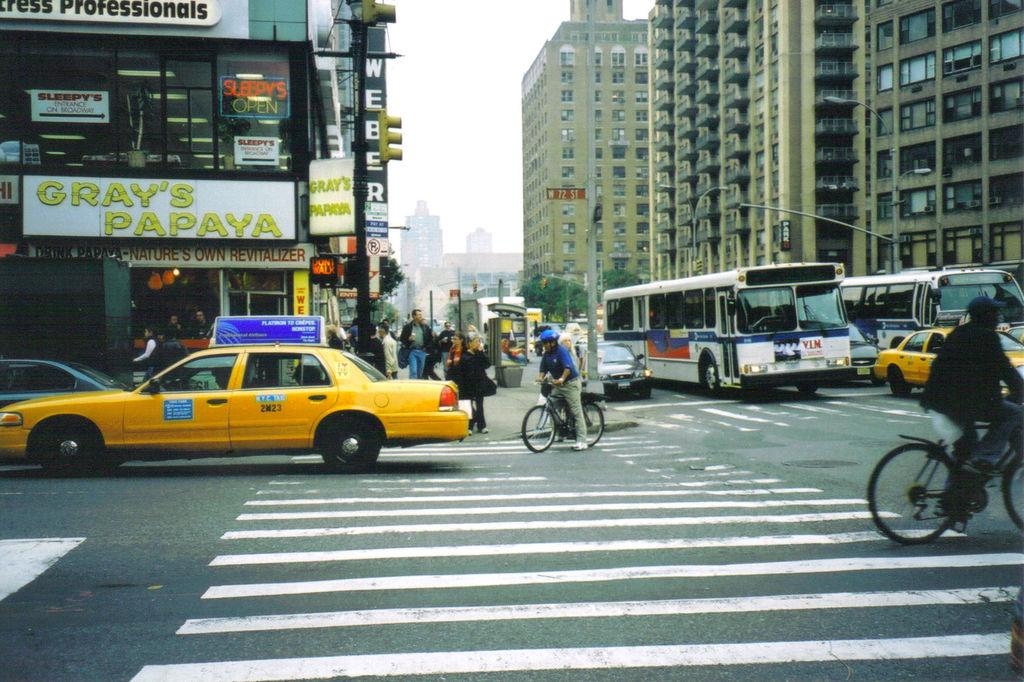<image>
Present a compact description of the photo's key features. A yellow cab crosses an intersection below a sign that says Gray's Papaya. 